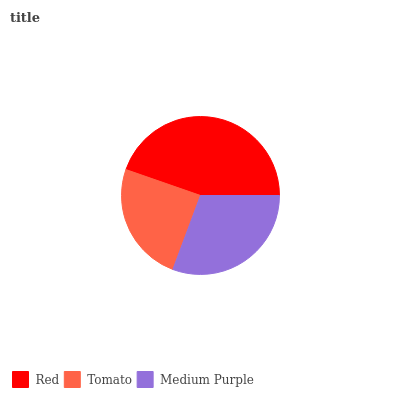Is Tomato the minimum?
Answer yes or no. Yes. Is Red the maximum?
Answer yes or no. Yes. Is Medium Purple the minimum?
Answer yes or no. No. Is Medium Purple the maximum?
Answer yes or no. No. Is Medium Purple greater than Tomato?
Answer yes or no. Yes. Is Tomato less than Medium Purple?
Answer yes or no. Yes. Is Tomato greater than Medium Purple?
Answer yes or no. No. Is Medium Purple less than Tomato?
Answer yes or no. No. Is Medium Purple the high median?
Answer yes or no. Yes. Is Medium Purple the low median?
Answer yes or no. Yes. Is Red the high median?
Answer yes or no. No. Is Red the low median?
Answer yes or no. No. 